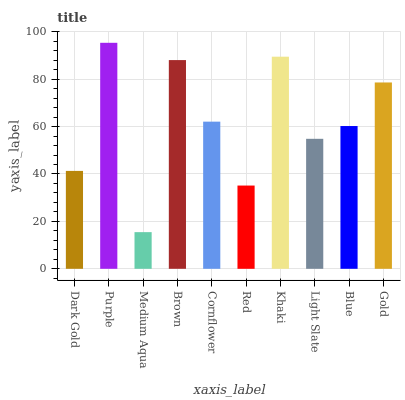Is Medium Aqua the minimum?
Answer yes or no. Yes. Is Purple the maximum?
Answer yes or no. Yes. Is Purple the minimum?
Answer yes or no. No. Is Medium Aqua the maximum?
Answer yes or no. No. Is Purple greater than Medium Aqua?
Answer yes or no. Yes. Is Medium Aqua less than Purple?
Answer yes or no. Yes. Is Medium Aqua greater than Purple?
Answer yes or no. No. Is Purple less than Medium Aqua?
Answer yes or no. No. Is Cornflower the high median?
Answer yes or no. Yes. Is Blue the low median?
Answer yes or no. Yes. Is Dark Gold the high median?
Answer yes or no. No. Is Gold the low median?
Answer yes or no. No. 